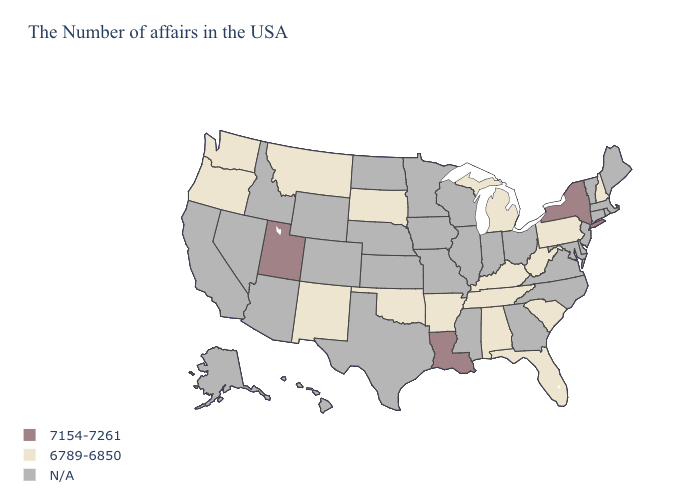Name the states that have a value in the range N/A?
Quick response, please. Maine, Massachusetts, Rhode Island, Vermont, Connecticut, New Jersey, Delaware, Maryland, Virginia, North Carolina, Ohio, Georgia, Indiana, Wisconsin, Illinois, Mississippi, Missouri, Minnesota, Iowa, Kansas, Nebraska, Texas, North Dakota, Wyoming, Colorado, Arizona, Idaho, Nevada, California, Alaska, Hawaii. Name the states that have a value in the range 6789-6850?
Short answer required. New Hampshire, Pennsylvania, South Carolina, West Virginia, Florida, Michigan, Kentucky, Alabama, Tennessee, Arkansas, Oklahoma, South Dakota, New Mexico, Montana, Washington, Oregon. What is the lowest value in the West?
Answer briefly. 6789-6850. What is the lowest value in states that border New Jersey?
Concise answer only. 6789-6850. Which states have the highest value in the USA?
Keep it brief. New York, Louisiana, Utah. What is the value of Iowa?
Answer briefly. N/A. Which states have the lowest value in the South?
Keep it brief. South Carolina, West Virginia, Florida, Kentucky, Alabama, Tennessee, Arkansas, Oklahoma. Does Louisiana have the highest value in the South?
Quick response, please. Yes. What is the value of Wyoming?
Be succinct. N/A. What is the value of Texas?
Answer briefly. N/A. Does Louisiana have the lowest value in the USA?
Quick response, please. No. What is the value of Hawaii?
Quick response, please. N/A. Name the states that have a value in the range 7154-7261?
Quick response, please. New York, Louisiana, Utah. Which states have the lowest value in the Northeast?
Be succinct. New Hampshire, Pennsylvania. What is the value of Arkansas?
Quick response, please. 6789-6850. 